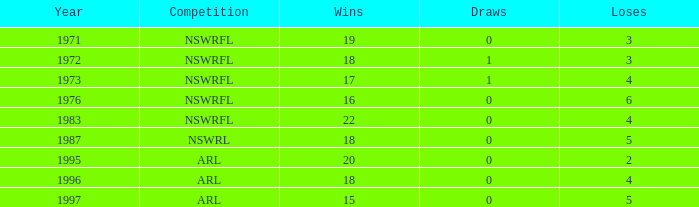Would you mind parsing the complete table? {'header': ['Year', 'Competition', 'Wins', 'Draws', 'Loses'], 'rows': [['1971', 'NSWRFL', '19', '0', '3'], ['1972', 'NSWRFL', '18', '1', '3'], ['1973', 'NSWRFL', '17', '1', '4'], ['1976', 'NSWRFL', '16', '0', '6'], ['1983', 'NSWRFL', '22', '0', '4'], ['1987', 'NSWRL', '18', '0', '5'], ['1995', 'ARL', '20', '0', '2'], ['1996', 'ARL', '18', '0', '4'], ['1997', 'ARL', '15', '0', '5']]} In which topmost year are there 15 victories and fewer than 5 defeats? None. 